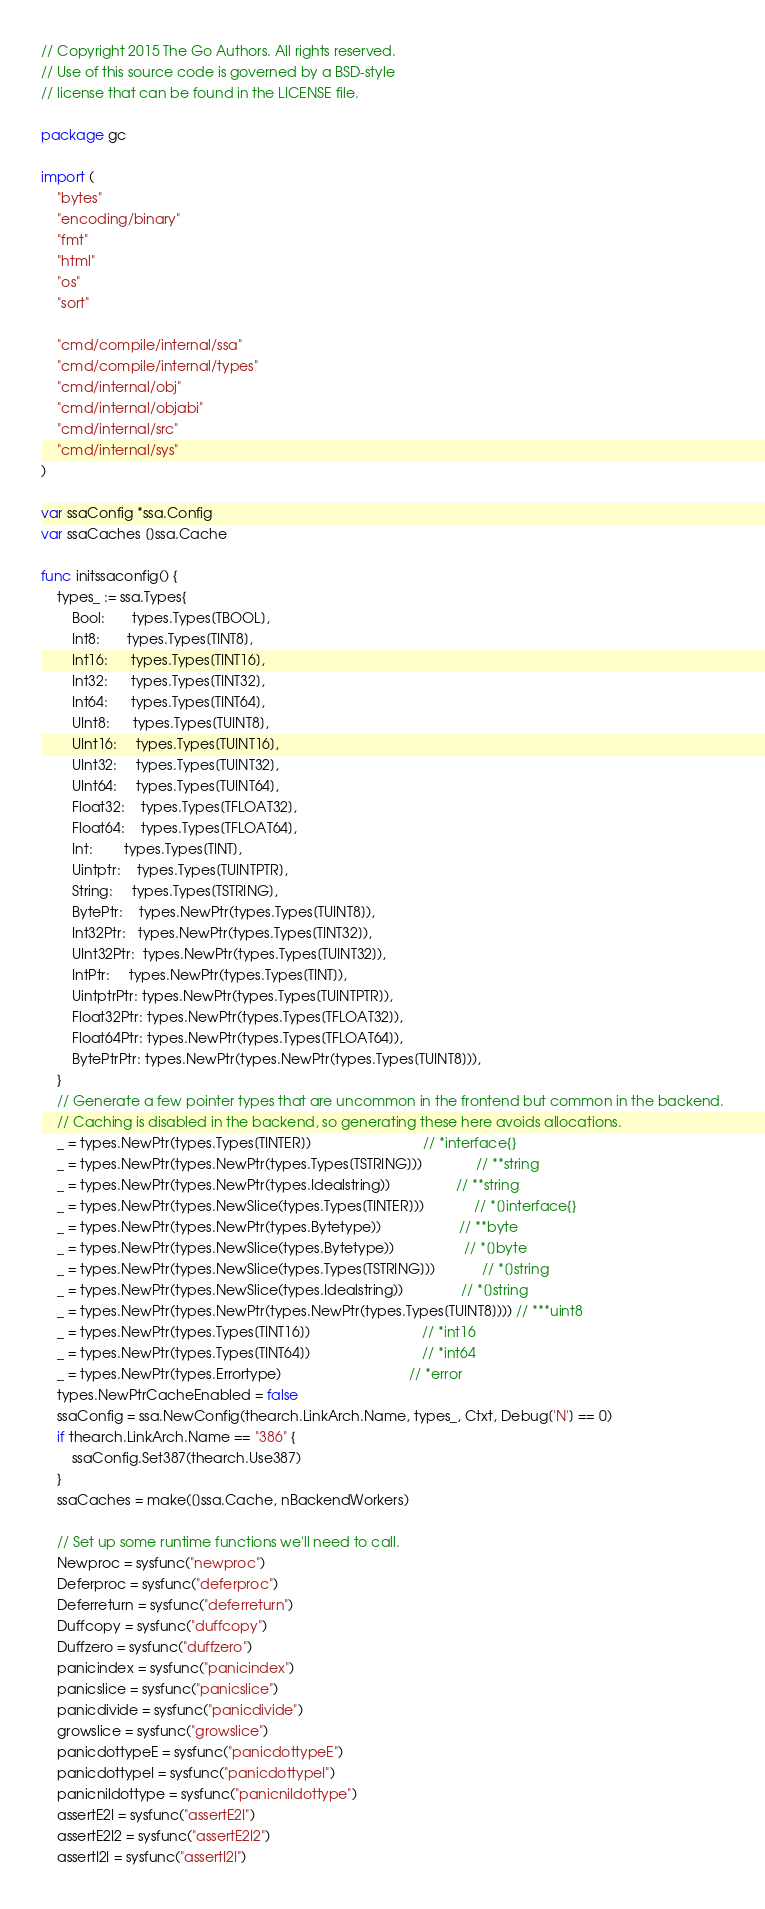Convert code to text. <code><loc_0><loc_0><loc_500><loc_500><_Go_>// Copyright 2015 The Go Authors. All rights reserved.
// Use of this source code is governed by a BSD-style
// license that can be found in the LICENSE file.

package gc

import (
	"bytes"
	"encoding/binary"
	"fmt"
	"html"
	"os"
	"sort"

	"cmd/compile/internal/ssa"
	"cmd/compile/internal/types"
	"cmd/internal/obj"
	"cmd/internal/objabi"
	"cmd/internal/src"
	"cmd/internal/sys"
)

var ssaConfig *ssa.Config
var ssaCaches []ssa.Cache

func initssaconfig() {
	types_ := ssa.Types{
		Bool:       types.Types[TBOOL],
		Int8:       types.Types[TINT8],
		Int16:      types.Types[TINT16],
		Int32:      types.Types[TINT32],
		Int64:      types.Types[TINT64],
		UInt8:      types.Types[TUINT8],
		UInt16:     types.Types[TUINT16],
		UInt32:     types.Types[TUINT32],
		UInt64:     types.Types[TUINT64],
		Float32:    types.Types[TFLOAT32],
		Float64:    types.Types[TFLOAT64],
		Int:        types.Types[TINT],
		Uintptr:    types.Types[TUINTPTR],
		String:     types.Types[TSTRING],
		BytePtr:    types.NewPtr(types.Types[TUINT8]),
		Int32Ptr:   types.NewPtr(types.Types[TINT32]),
		UInt32Ptr:  types.NewPtr(types.Types[TUINT32]),
		IntPtr:     types.NewPtr(types.Types[TINT]),
		UintptrPtr: types.NewPtr(types.Types[TUINTPTR]),
		Float32Ptr: types.NewPtr(types.Types[TFLOAT32]),
		Float64Ptr: types.NewPtr(types.Types[TFLOAT64]),
		BytePtrPtr: types.NewPtr(types.NewPtr(types.Types[TUINT8])),
	}
	// Generate a few pointer types that are uncommon in the frontend but common in the backend.
	// Caching is disabled in the backend, so generating these here avoids allocations.
	_ = types.NewPtr(types.Types[TINTER])                             // *interface{}
	_ = types.NewPtr(types.NewPtr(types.Types[TSTRING]))              // **string
	_ = types.NewPtr(types.NewPtr(types.Idealstring))                 // **string
	_ = types.NewPtr(types.NewSlice(types.Types[TINTER]))             // *[]interface{}
	_ = types.NewPtr(types.NewPtr(types.Bytetype))                    // **byte
	_ = types.NewPtr(types.NewSlice(types.Bytetype))                  // *[]byte
	_ = types.NewPtr(types.NewSlice(types.Types[TSTRING]))            // *[]string
	_ = types.NewPtr(types.NewSlice(types.Idealstring))               // *[]string
	_ = types.NewPtr(types.NewPtr(types.NewPtr(types.Types[TUINT8]))) // ***uint8
	_ = types.NewPtr(types.Types[TINT16])                             // *int16
	_ = types.NewPtr(types.Types[TINT64])                             // *int64
	_ = types.NewPtr(types.Errortype)                                 // *error
	types.NewPtrCacheEnabled = false
	ssaConfig = ssa.NewConfig(thearch.LinkArch.Name, types_, Ctxt, Debug['N'] == 0)
	if thearch.LinkArch.Name == "386" {
		ssaConfig.Set387(thearch.Use387)
	}
	ssaCaches = make([]ssa.Cache, nBackendWorkers)

	// Set up some runtime functions we'll need to call.
	Newproc = sysfunc("newproc")
	Deferproc = sysfunc("deferproc")
	Deferreturn = sysfunc("deferreturn")
	Duffcopy = sysfunc("duffcopy")
	Duffzero = sysfunc("duffzero")
	panicindex = sysfunc("panicindex")
	panicslice = sysfunc("panicslice")
	panicdivide = sysfunc("panicdivide")
	growslice = sysfunc("growslice")
	panicdottypeE = sysfunc("panicdottypeE")
	panicdottypeI = sysfunc("panicdottypeI")
	panicnildottype = sysfunc("panicnildottype")
	assertE2I = sysfunc("assertE2I")
	assertE2I2 = sysfunc("assertE2I2")
	assertI2I = sysfunc("assertI2I")</code> 